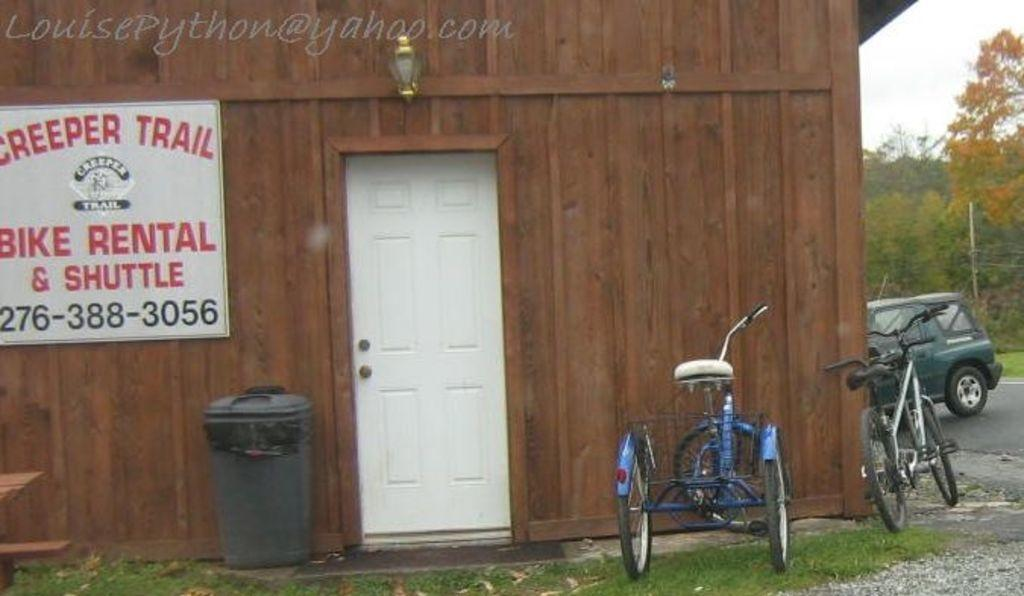What type of vehicles are in the image? There are bicycles and a car in the image. What is the setting of the image? The image features a road, grass, and trees in the background. What is the purpose of the dust bin in the image? The dust bin is likely for waste disposal. What is the wooden wall with a board used for? The board on the wooden wall might be used for displaying information or advertisements. What is the door in the image used for? The door is likely an entrance to a building or structure. What is visible in the background of the image? There is a pole, trees, and sky visible in the background of the image. How many pens are used to measure the distance between the bicycles and the car in the image? There are no pens present in the image, and the distance between the bicycles and the car cannot be measured using pens. 